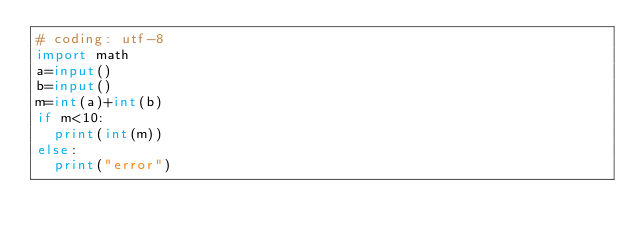Convert code to text. <code><loc_0><loc_0><loc_500><loc_500><_Python_># coding: utf-8
import math
a=input()
b=input()
m=int(a)+int(b)
if m<10:
  print(int(m))
else:
  print("error")</code> 